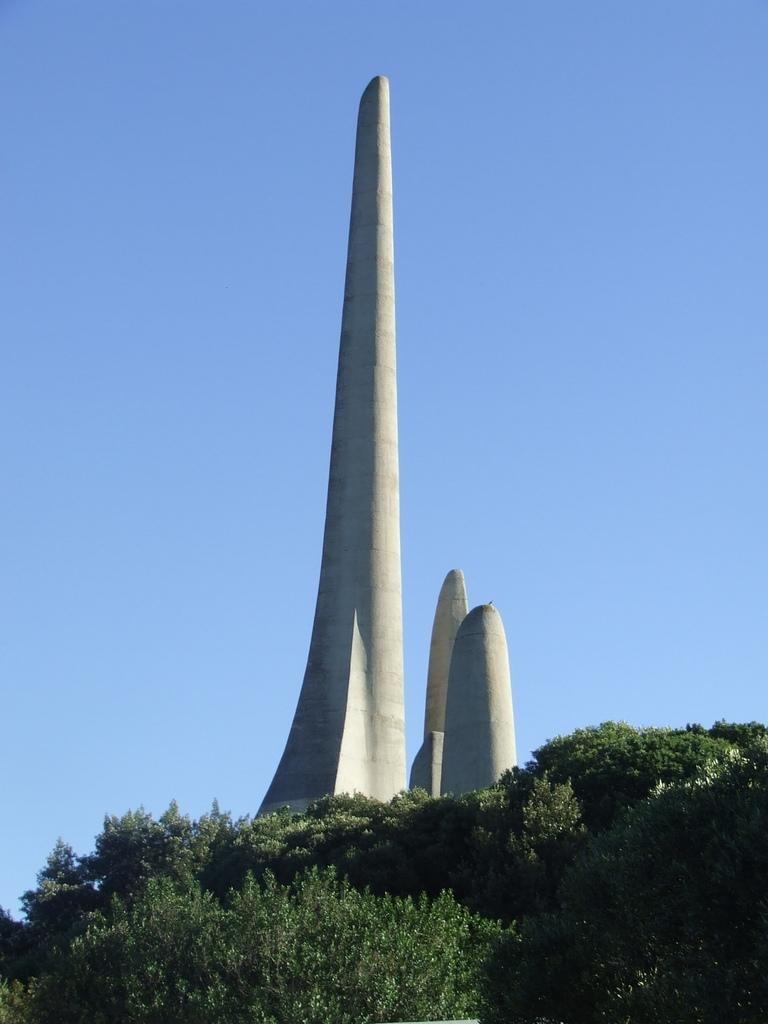What is the main structure in the middle of the image? There is a big cement pillar in the middle of the image. Are there any other pillars in the image? Yes, there are two small pillars beside the big pillar. What type of vegetation is at the bottom of the image? There are plants at the bottom of the image. What is visible at the top of the image? The sky is visible at the top of the image. Can you see the sea in the background of the image? There is no sea visible in the image; it only shows a big cement pillar, two small pillars, plants, and the sky. 